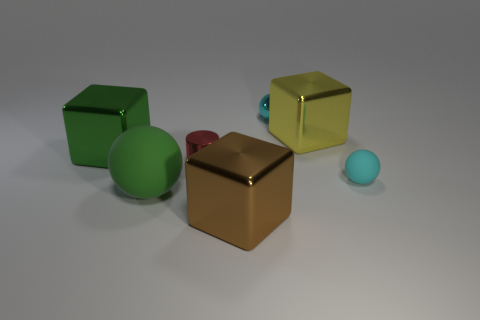Add 1 large green metallic objects. How many objects exist? 8 Subtract all spheres. How many objects are left? 4 Add 7 large green objects. How many large green objects are left? 9 Add 7 big cyan cubes. How many big cyan cubes exist? 7 Subtract 1 cyan spheres. How many objects are left? 6 Subtract all red cylinders. Subtract all big red shiny cylinders. How many objects are left? 6 